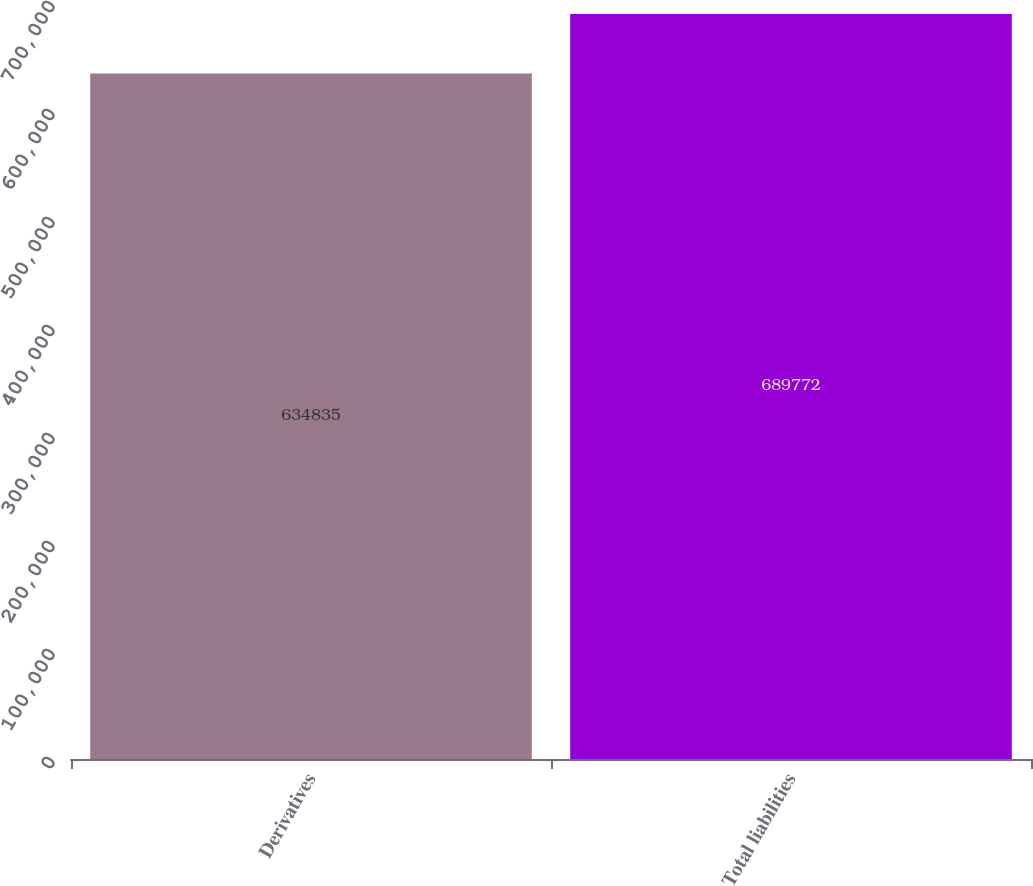<chart> <loc_0><loc_0><loc_500><loc_500><bar_chart><fcel>Derivatives<fcel>Total liabilities<nl><fcel>634835<fcel>689772<nl></chart> 